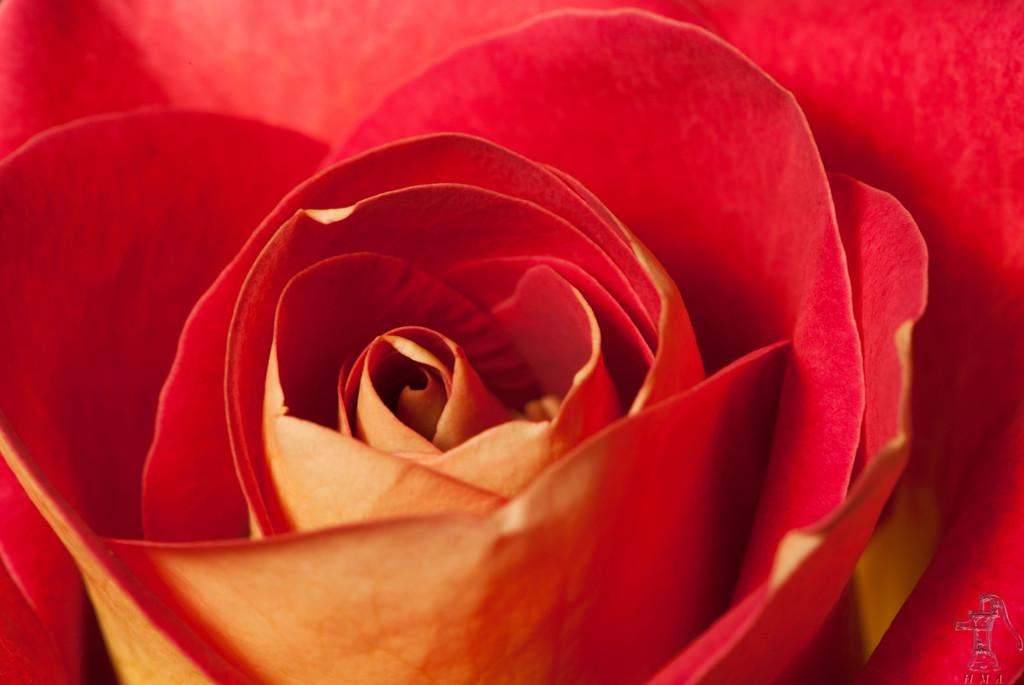What type of flower is in the image? There is a rose flower in the image. What color is the rose flower? The rose flower is red in color. Can you see the tramp jumping over the hill in the image? There is no tramp or hill present in the image; it only features a red rose flower. 